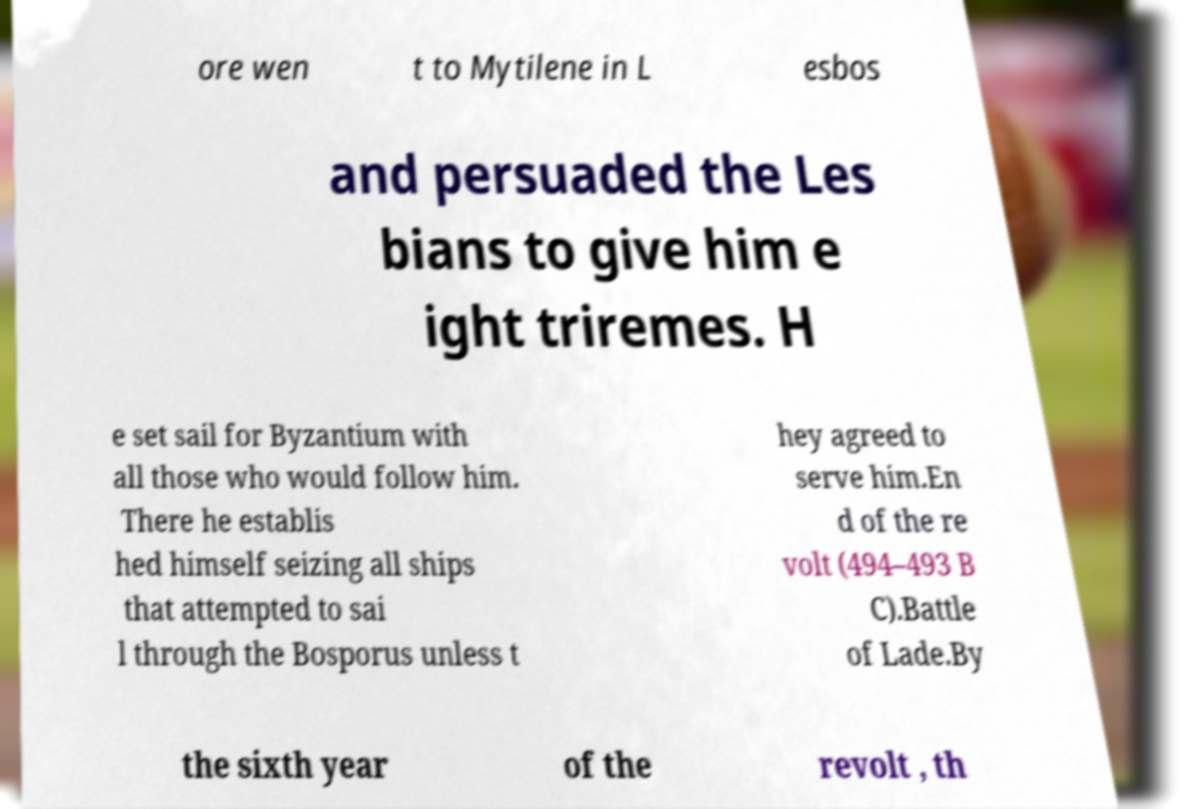Could you assist in decoding the text presented in this image and type it out clearly? ore wen t to Mytilene in L esbos and persuaded the Les bians to give him e ight triremes. H e set sail for Byzantium with all those who would follow him. There he establis hed himself seizing all ships that attempted to sai l through the Bosporus unless t hey agreed to serve him.En d of the re volt (494–493 B C).Battle of Lade.By the sixth year of the revolt , th 